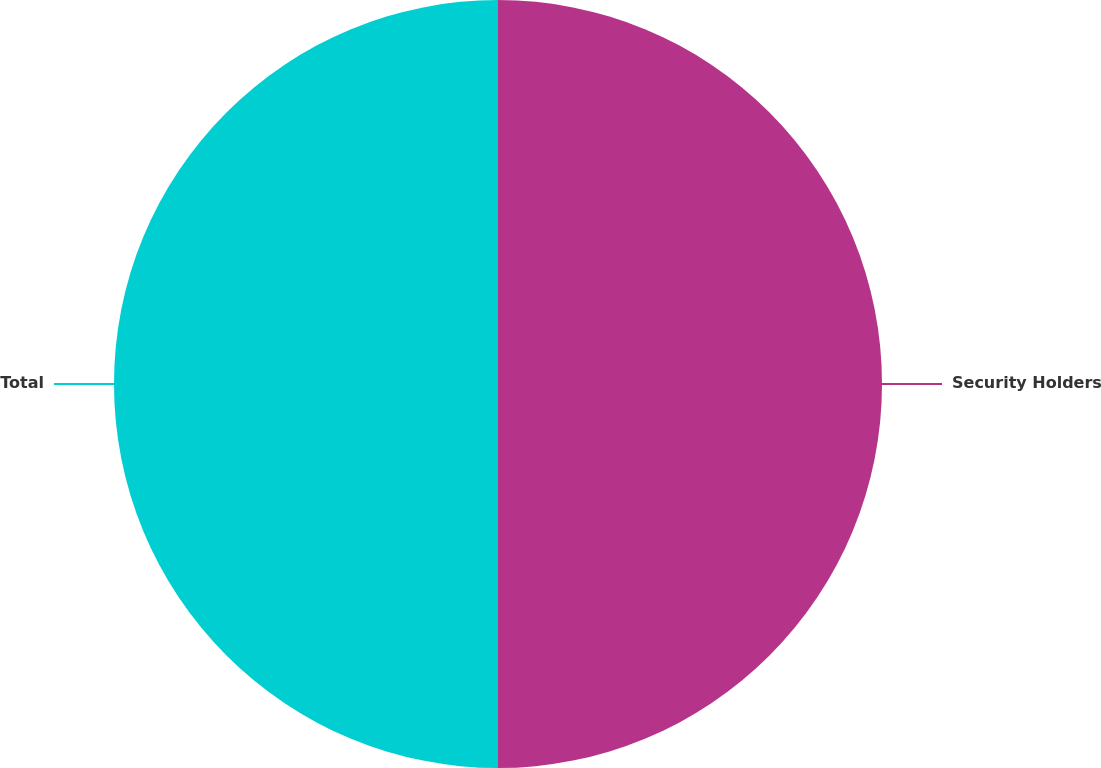<chart> <loc_0><loc_0><loc_500><loc_500><pie_chart><fcel>Security Holders<fcel>Total<nl><fcel>50.0%<fcel>50.0%<nl></chart> 